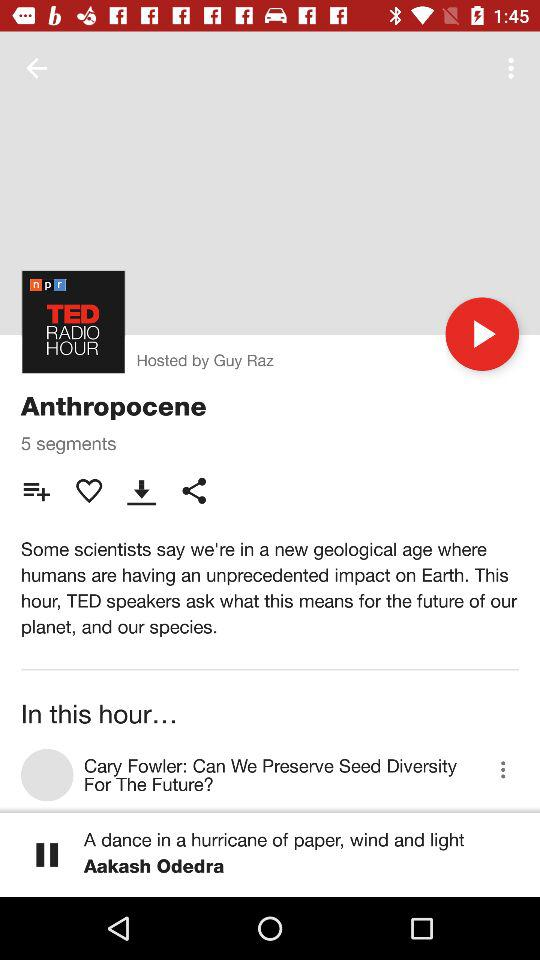How many segments are there in the TED show? There are 5 segments in the TED show. 